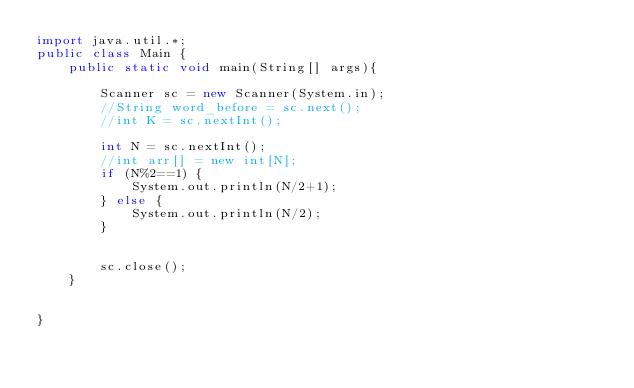Convert code to text. <code><loc_0><loc_0><loc_500><loc_500><_Java_>import java.util.*;
public class Main {
	public static void main(String[] args){
      	
		Scanner sc = new Scanner(System.in);
		//String word_before = sc.next();
		//int K = sc.nextInt();
		
		int N = sc.nextInt();
		//int arr[] = new int[N];
		if (N%2==1) {
			System.out.println(N/2+1);
		} else {
			System.out.println(N/2);
		}
		
		
      	sc.close();
    }
		
		
}
</code> 